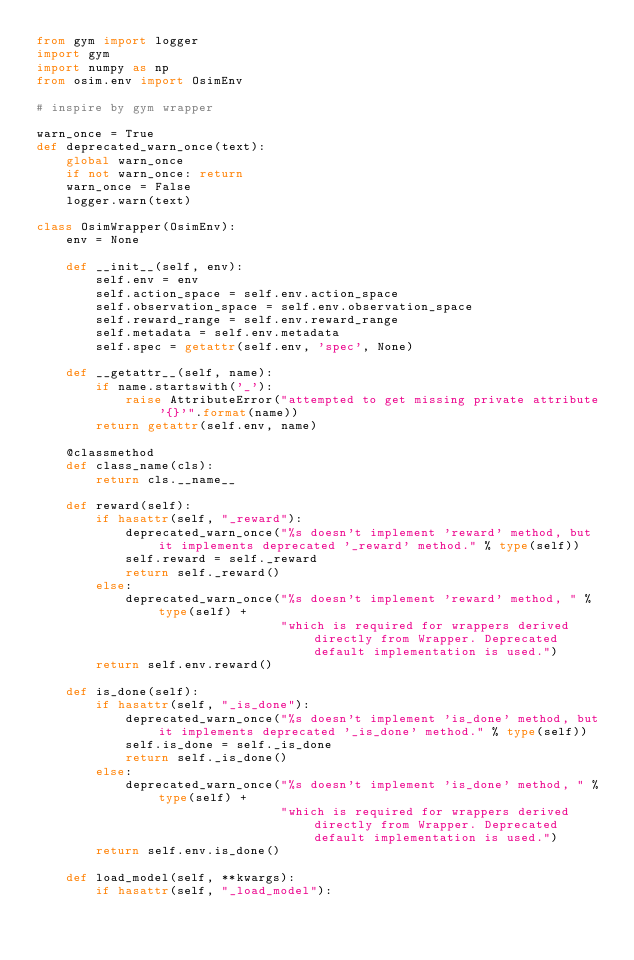<code> <loc_0><loc_0><loc_500><loc_500><_Python_>from gym import logger
import gym
import numpy as np
from osim.env import OsimEnv

# inspire by gym wrapper

warn_once = True
def deprecated_warn_once(text):
    global warn_once
    if not warn_once: return
    warn_once = False
    logger.warn(text)

class OsimWrapper(OsimEnv):
    env = None

    def __init__(self, env):
        self.env = env
        self.action_space = self.env.action_space
        self.observation_space = self.env.observation_space
        self.reward_range = self.env.reward_range
        self.metadata = self.env.metadata
        self.spec = getattr(self.env, 'spec', None)

    def __getattr__(self, name):
        if name.startswith('_'):
            raise AttributeError("attempted to get missing private attribute '{}'".format(name))
        return getattr(self.env, name)

    @classmethod
    def class_name(cls):
        return cls.__name__

    def reward(self):
        if hasattr(self, "_reward"):
            deprecated_warn_once("%s doesn't implement 'reward' method, but it implements deprecated '_reward' method." % type(self))
            self.reward = self._reward
            return self._reward()
        else:
            deprecated_warn_once("%s doesn't implement 'reward' method, " % type(self) +
                                 "which is required for wrappers derived directly from Wrapper. Deprecated default implementation is used.")
        return self.env.reward()

    def is_done(self):
        if hasattr(self, "_is_done"):
            deprecated_warn_once("%s doesn't implement 'is_done' method, but it implements deprecated '_is_done' method." % type(self))
            self.is_done = self._is_done
            return self._is_done()
        else:
            deprecated_warn_once("%s doesn't implement 'is_done' method, " % type(self) +
                                 "which is required for wrappers derived directly from Wrapper. Deprecated default implementation is used.")
        return self.env.is_done()

    def load_model(self, **kwargs):
        if hasattr(self, "_load_model"):</code> 